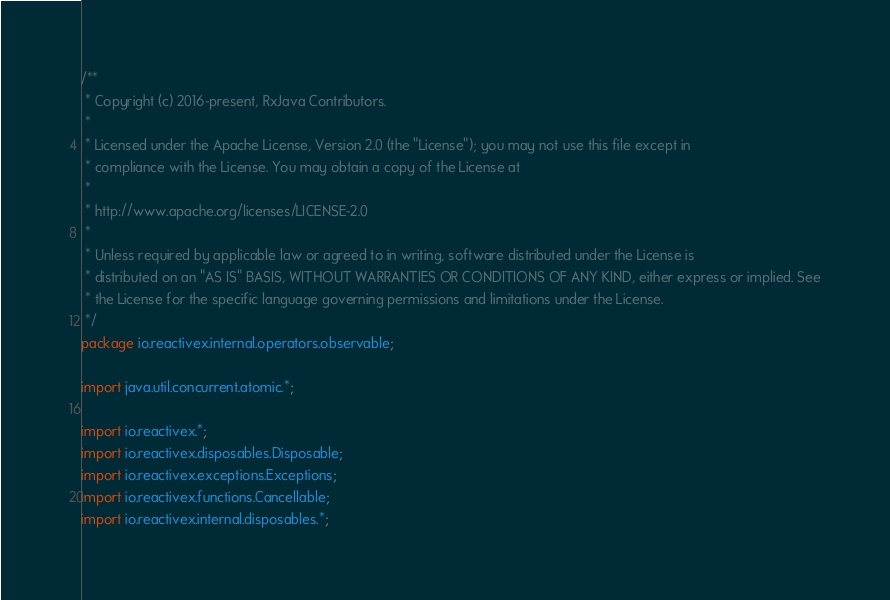<code> <loc_0><loc_0><loc_500><loc_500><_Java_>/**
 * Copyright (c) 2016-present, RxJava Contributors.
 *
 * Licensed under the Apache License, Version 2.0 (the "License"); you may not use this file except in
 * compliance with the License. You may obtain a copy of the License at
 *
 * http://www.apache.org/licenses/LICENSE-2.0
 *
 * Unless required by applicable law or agreed to in writing, software distributed under the License is
 * distributed on an "AS IS" BASIS, WITHOUT WARRANTIES OR CONDITIONS OF ANY KIND, either express or implied. See
 * the License for the specific language governing permissions and limitations under the License.
 */
package io.reactivex.internal.operators.observable;

import java.util.concurrent.atomic.*;

import io.reactivex.*;
import io.reactivex.disposables.Disposable;
import io.reactivex.exceptions.Exceptions;
import io.reactivex.functions.Cancellable;
import io.reactivex.internal.disposables.*;</code> 